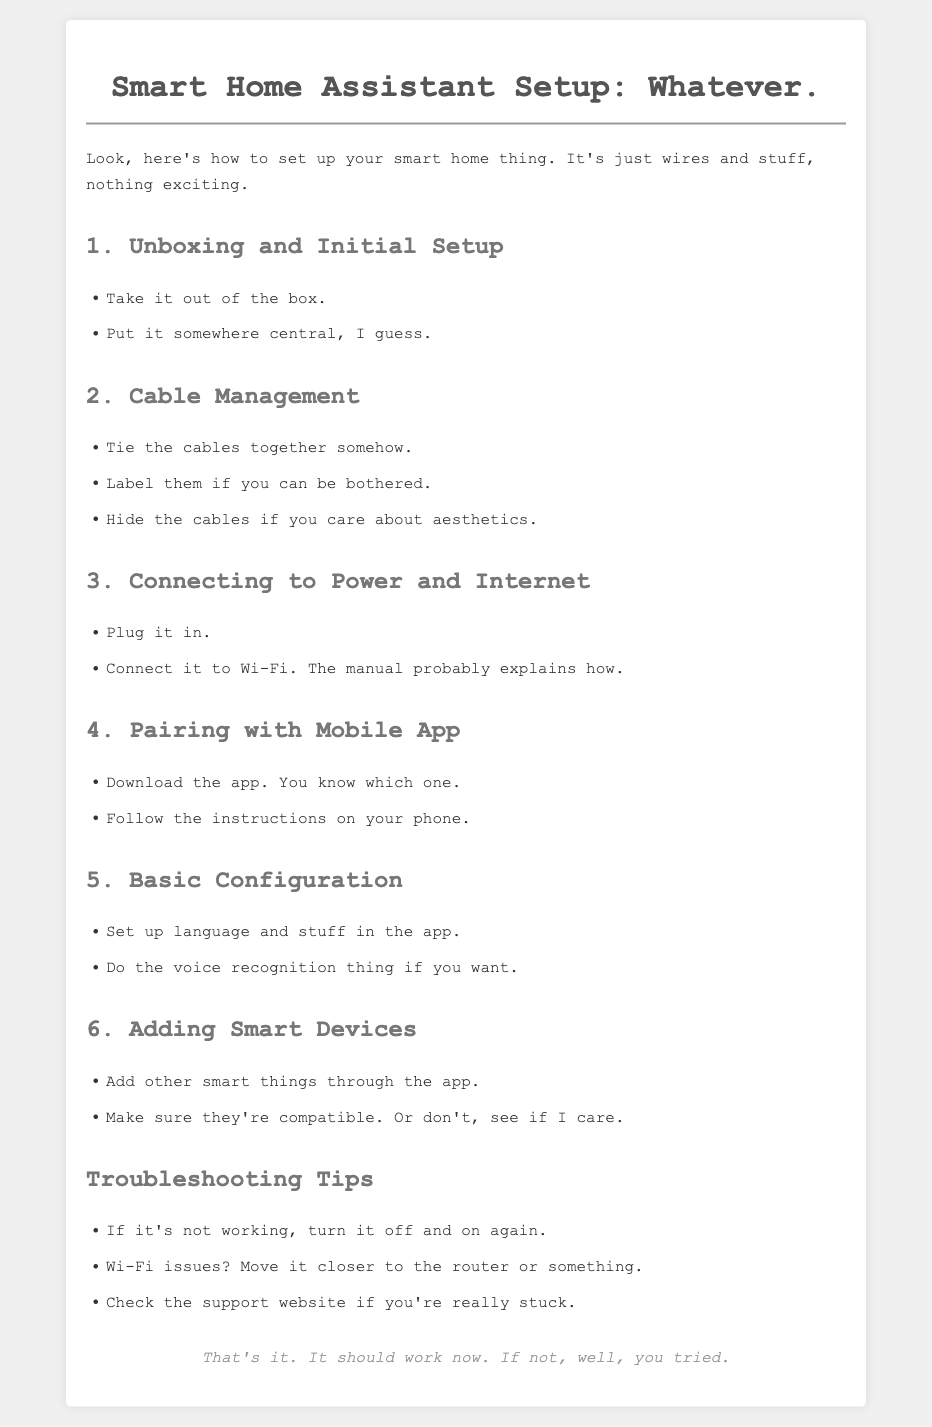what is the title of the document? The title is the main heading of the document that provides the subject matter.
Answer: Smart Home Assistant Setup: Whatever how many steps are outlined in the setup process? The steps are numbered and listed clearly in the document.
Answer: 6 what is the first step in the setup process? The first step is the initial action required to start the setup.
Answer: Unboxing and Initial Setup what does the user need to do for cable management? This refers to the specific actions suggested for organizing cables.
Answer: Tie the cables together somehow which tip is suggested for troubleshooting Wi-Fi issues? This addresses possible solutions for a common issue mentioned in the troubleshooting section.
Answer: Move it closer to the router what should be done if the device is not working? This indicates an immediate action to take according to the troubleshooting tips.
Answer: Turn it off and on again what should the user do to pair the device with a mobile app? This specifies the action required to connect the device to a mobile platform.
Answer: Download the app how does the document suggest to customize the device? This involves adjusting settings to suit the user's preferences as mentioned in the configuration step.
Answer: Set up language and stuff in the app 